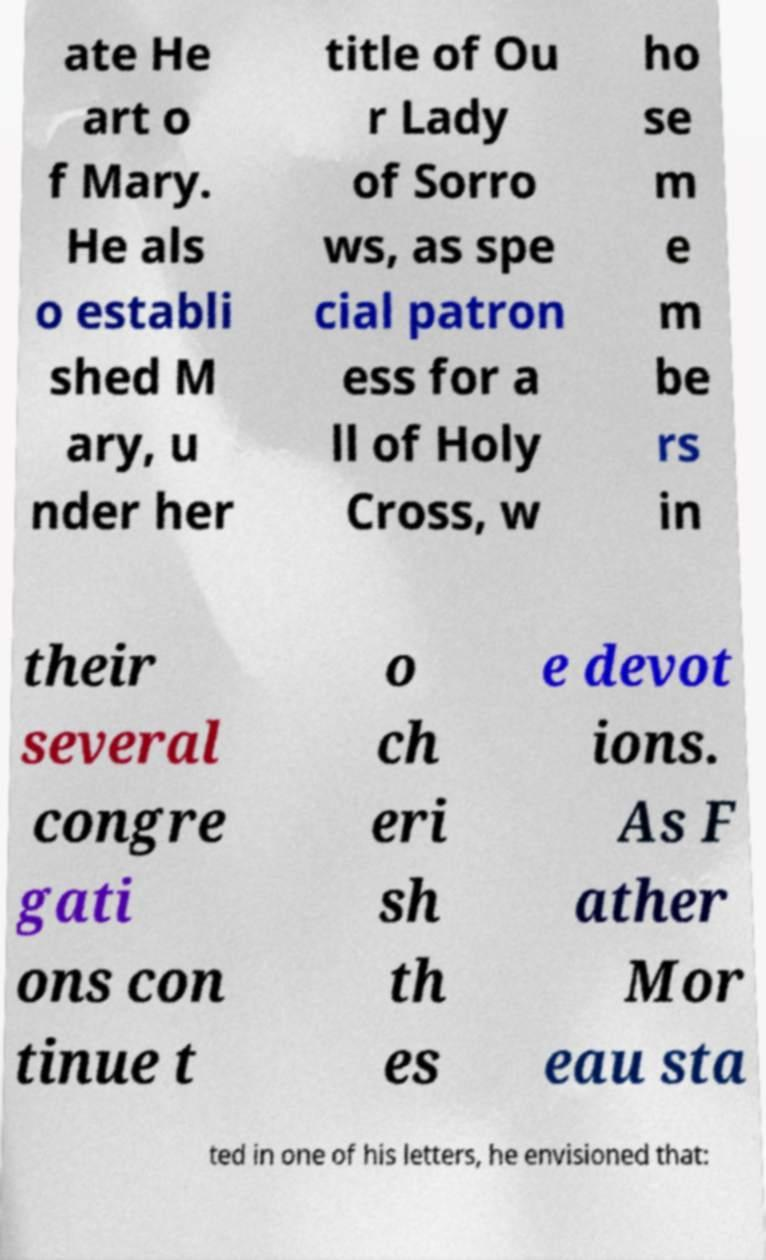What messages or text are displayed in this image? I need them in a readable, typed format. ate He art o f Mary. He als o establi shed M ary, u nder her title of Ou r Lady of Sorro ws, as spe cial patron ess for a ll of Holy Cross, w ho se m e m be rs in their several congre gati ons con tinue t o ch eri sh th es e devot ions. As F ather Mor eau sta ted in one of his letters, he envisioned that: 